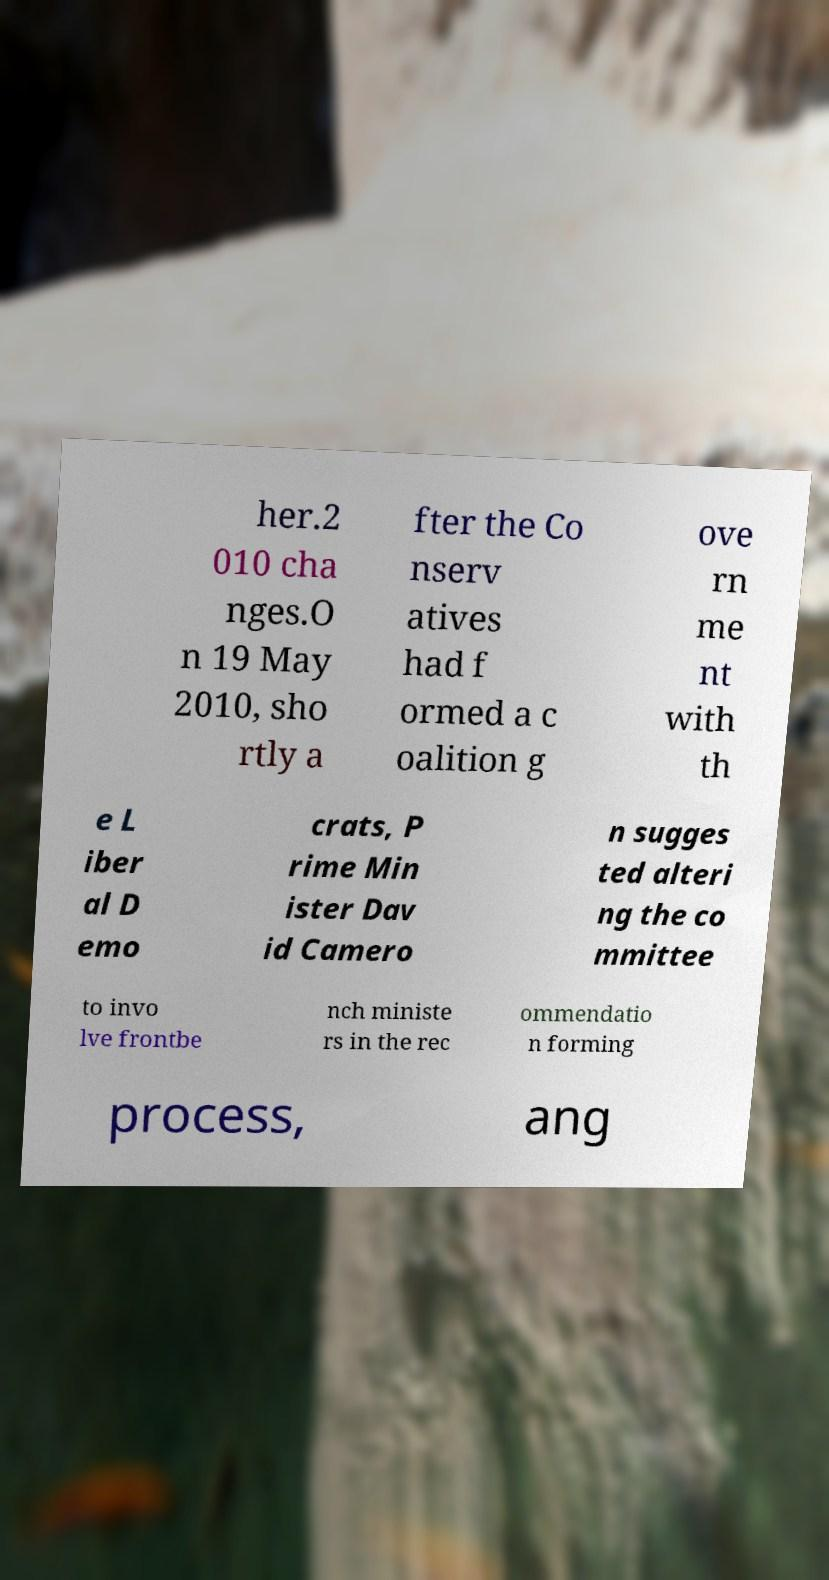Please read and relay the text visible in this image. What does it say? her.2 010 cha nges.O n 19 May 2010, sho rtly a fter the Co nserv atives had f ormed a c oalition g ove rn me nt with th e L iber al D emo crats, P rime Min ister Dav id Camero n sugges ted alteri ng the co mmittee to invo lve frontbe nch ministe rs in the rec ommendatio n forming process, ang 